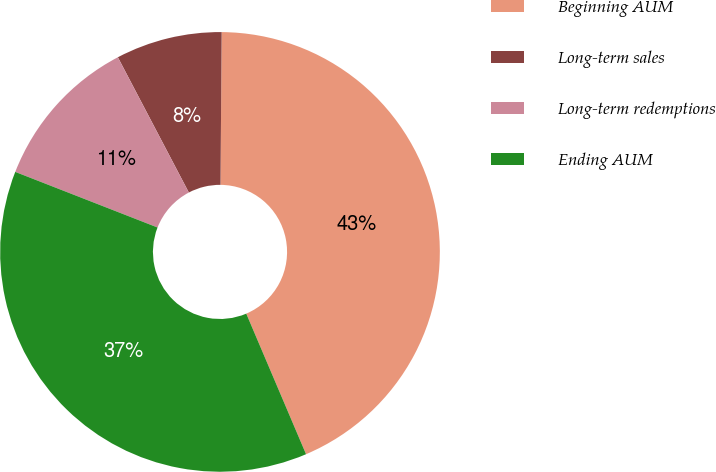Convert chart. <chart><loc_0><loc_0><loc_500><loc_500><pie_chart><fcel>Beginning AUM<fcel>Long-term sales<fcel>Long-term redemptions<fcel>Ending AUM<nl><fcel>43.48%<fcel>7.81%<fcel>11.38%<fcel>37.33%<nl></chart> 